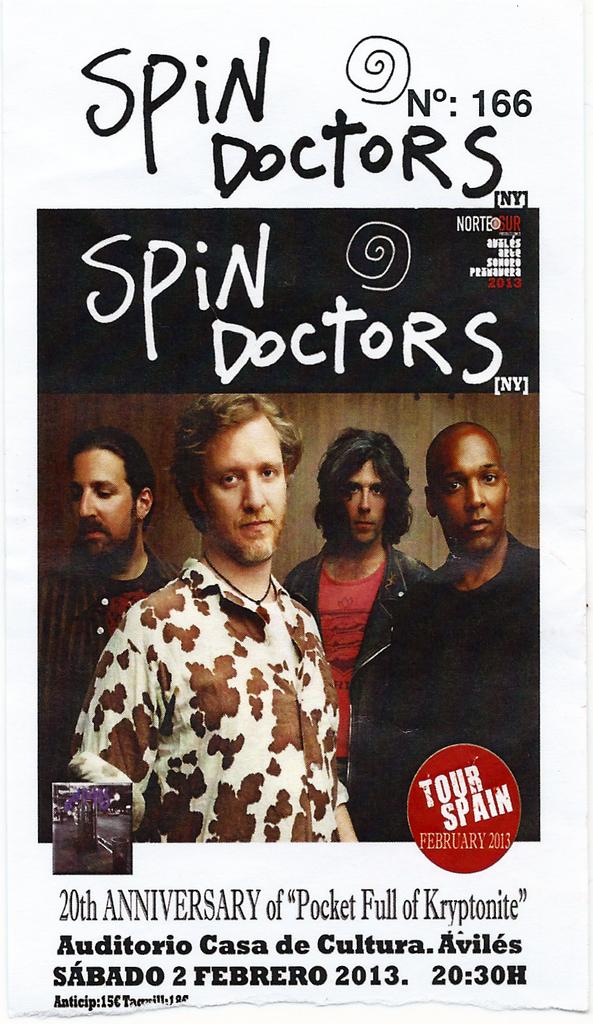What is the band's name?
Your answer should be compact. Spin doctors. What is the name of the doctor?
Provide a short and direct response. Spin doctors. 